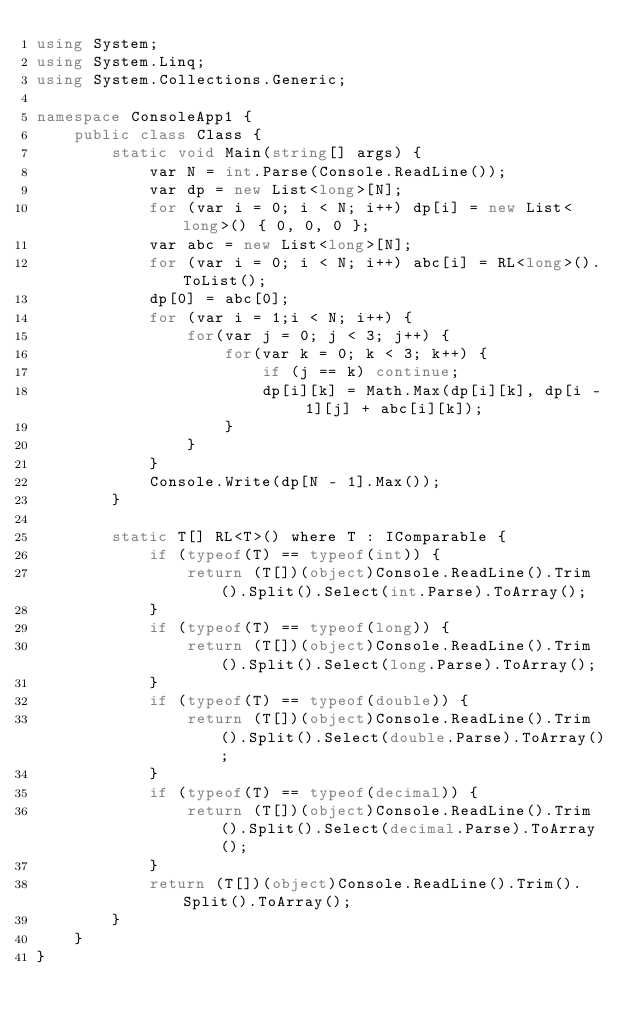<code> <loc_0><loc_0><loc_500><loc_500><_C#_>using System;
using System.Linq;
using System.Collections.Generic;

namespace ConsoleApp1 {
    public class Class {
        static void Main(string[] args) {
            var N = int.Parse(Console.ReadLine());
            var dp = new List<long>[N];
            for (var i = 0; i < N; i++) dp[i] = new List<long>() { 0, 0, 0 };
            var abc = new List<long>[N];
            for (var i = 0; i < N; i++) abc[i] = RL<long>().ToList();
            dp[0] = abc[0];
            for (var i = 1;i < N; i++) {
                for(var j = 0; j < 3; j++) {
                    for(var k = 0; k < 3; k++) {
                        if (j == k) continue;
                        dp[i][k] = Math.Max(dp[i][k], dp[i - 1][j] + abc[i][k]);
                    }
                }
            }
            Console.Write(dp[N - 1].Max());
        }

        static T[] RL<T>() where T : IComparable {
            if (typeof(T) == typeof(int)) {
                return (T[])(object)Console.ReadLine().Trim().Split().Select(int.Parse).ToArray();
            }
            if (typeof(T) == typeof(long)) {
                return (T[])(object)Console.ReadLine().Trim().Split().Select(long.Parse).ToArray();
            }
            if (typeof(T) == typeof(double)) {
                return (T[])(object)Console.ReadLine().Trim().Split().Select(double.Parse).ToArray();
            }
            if (typeof(T) == typeof(decimal)) {
                return (T[])(object)Console.ReadLine().Trim().Split().Select(decimal.Parse).ToArray();
            }
            return (T[])(object)Console.ReadLine().Trim().Split().ToArray();
        }
    }
}</code> 